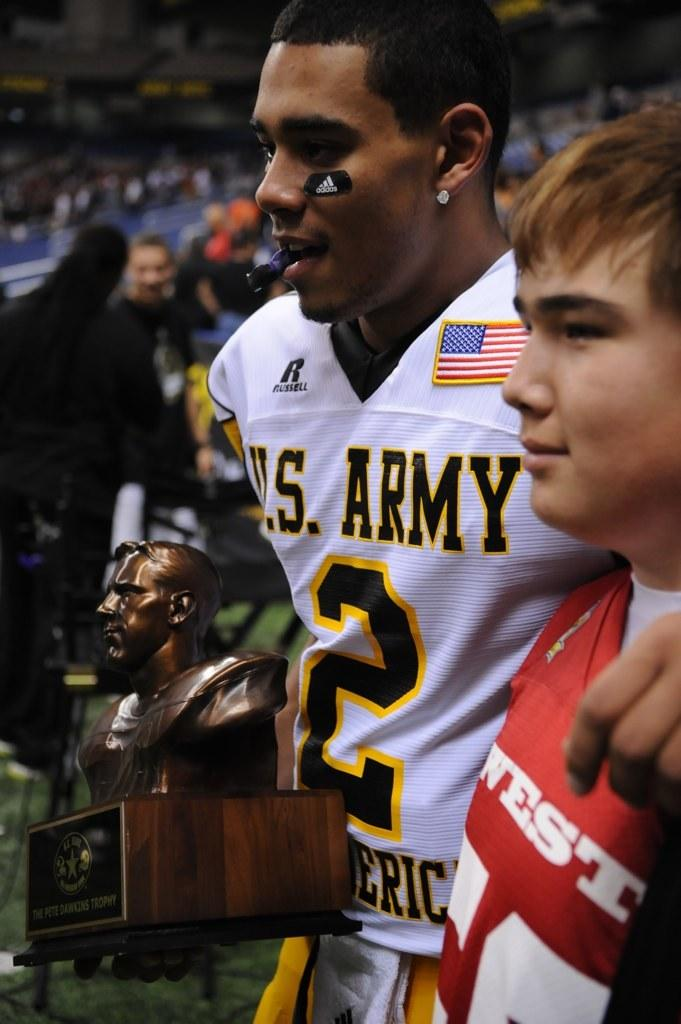<image>
Present a compact description of the photo's key features. A player wearing a US Army All American jersey holds a trophy while embracing a boy. 